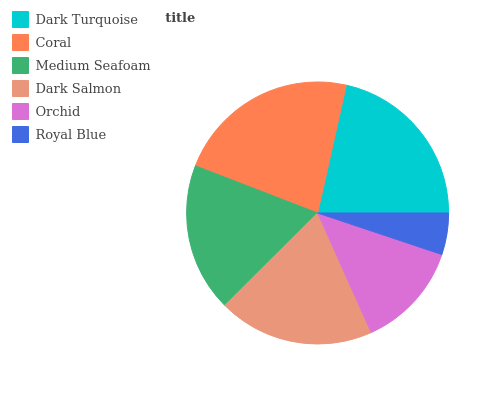Is Royal Blue the minimum?
Answer yes or no. Yes. Is Coral the maximum?
Answer yes or no. Yes. Is Medium Seafoam the minimum?
Answer yes or no. No. Is Medium Seafoam the maximum?
Answer yes or no. No. Is Coral greater than Medium Seafoam?
Answer yes or no. Yes. Is Medium Seafoam less than Coral?
Answer yes or no. Yes. Is Medium Seafoam greater than Coral?
Answer yes or no. No. Is Coral less than Medium Seafoam?
Answer yes or no. No. Is Dark Salmon the high median?
Answer yes or no. Yes. Is Medium Seafoam the low median?
Answer yes or no. Yes. Is Medium Seafoam the high median?
Answer yes or no. No. Is Dark Salmon the low median?
Answer yes or no. No. 